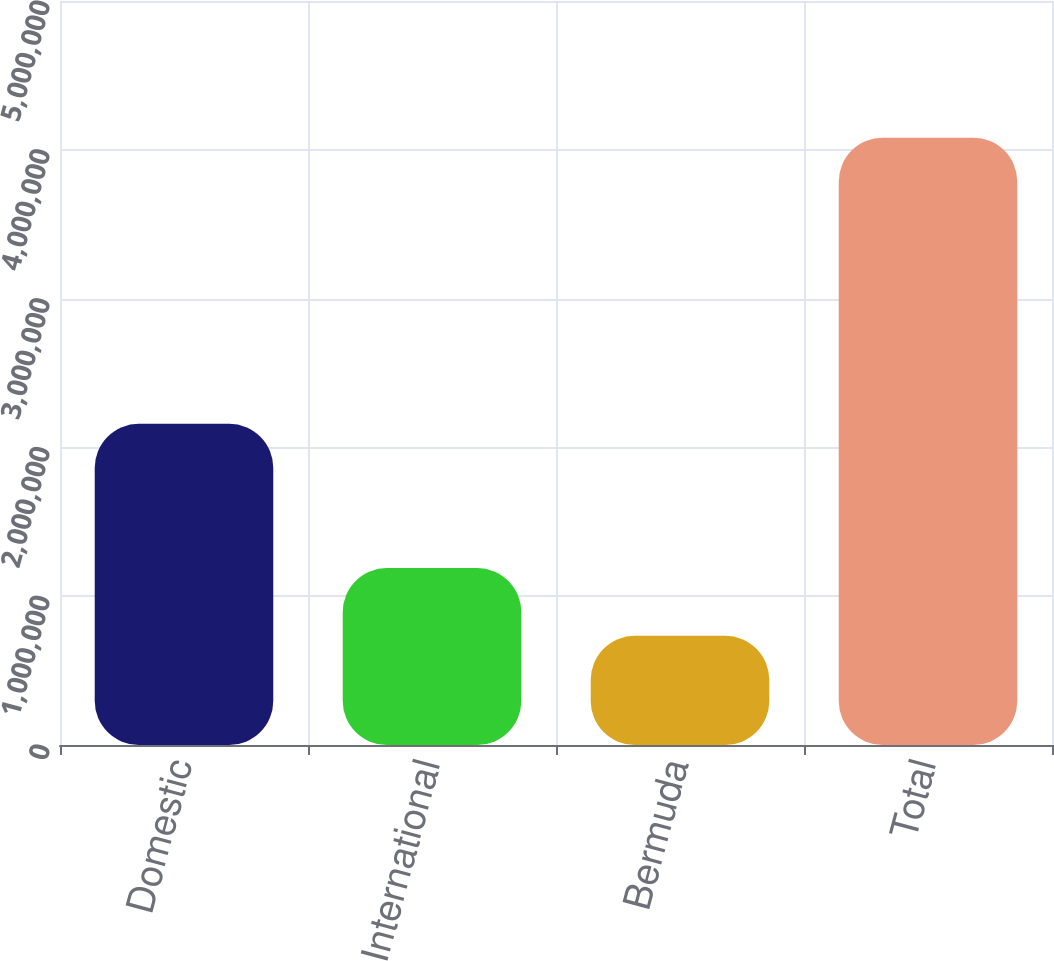Convert chart. <chart><loc_0><loc_0><loc_500><loc_500><bar_chart><fcel>Domestic<fcel>International<fcel>Bermuda<fcel>Total<nl><fcel>2.15858e+06<fcel>1.18874e+06<fcel>733751<fcel>4.08107e+06<nl></chart> 